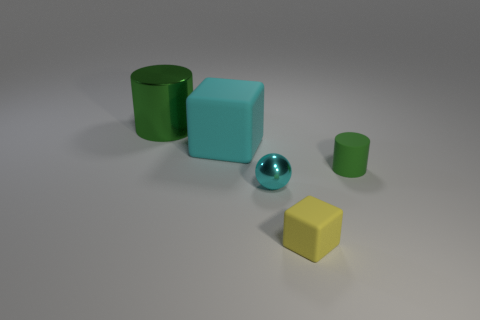Add 4 small green shiny balls. How many objects exist? 9 Subtract all cylinders. How many objects are left? 3 Subtract 0 gray cylinders. How many objects are left? 5 Subtract all large red metal cubes. Subtract all cyan things. How many objects are left? 3 Add 4 big matte objects. How many big matte objects are left? 5 Add 5 purple metal cubes. How many purple metal cubes exist? 5 